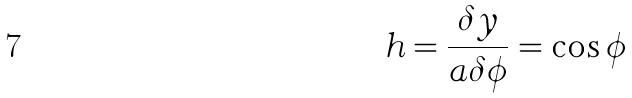Convert formula to latex. <formula><loc_0><loc_0><loc_500><loc_500>h = \frac { \delta y } { a \delta \phi } = \cos \phi</formula> 